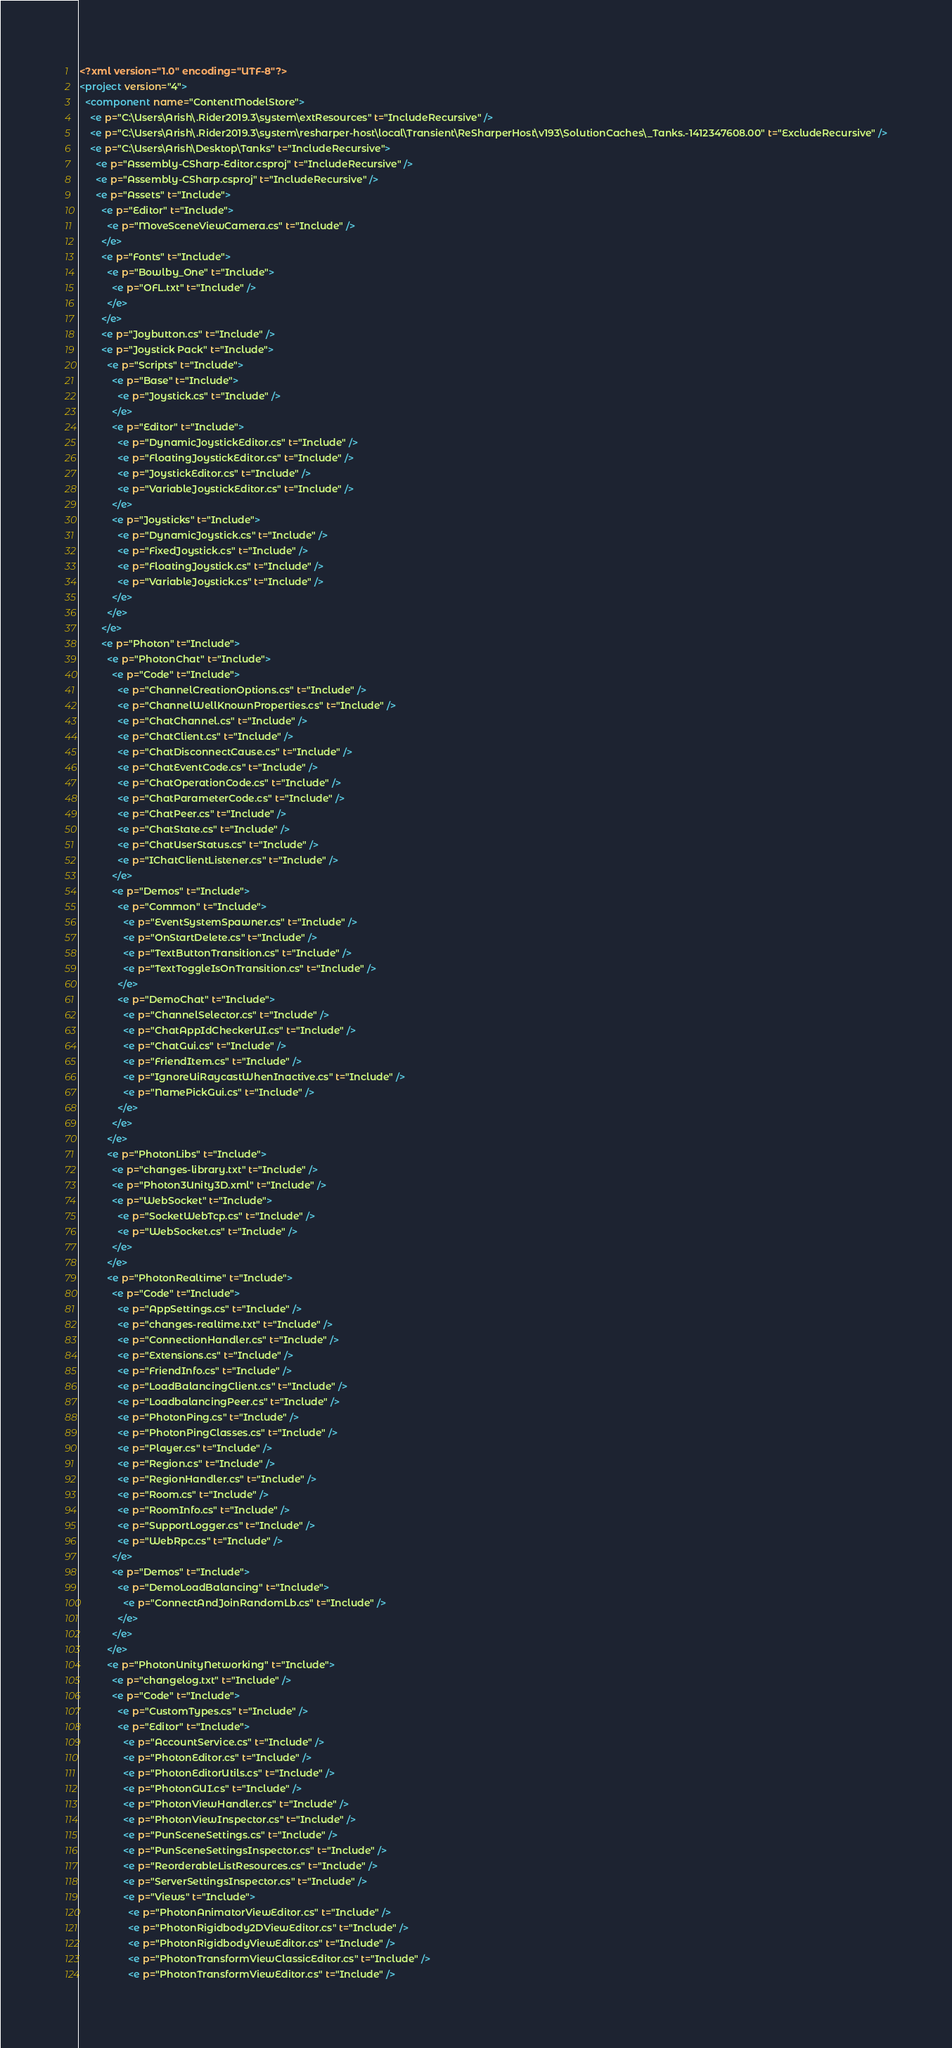Convert code to text. <code><loc_0><loc_0><loc_500><loc_500><_XML_><?xml version="1.0" encoding="UTF-8"?>
<project version="4">
  <component name="ContentModelStore">
    <e p="C:\Users\Arish\.Rider2019.3\system\extResources" t="IncludeRecursive" />
    <e p="C:\Users\Arish\.Rider2019.3\system\resharper-host\local\Transient\ReSharperHost\v193\SolutionCaches\_Tanks.-1412347608.00" t="ExcludeRecursive" />
    <e p="C:\Users\Arish\Desktop\Tanks" t="IncludeRecursive">
      <e p="Assembly-CSharp-Editor.csproj" t="IncludeRecursive" />
      <e p="Assembly-CSharp.csproj" t="IncludeRecursive" />
      <e p="Assets" t="Include">
        <e p="Editor" t="Include">
          <e p="MoveSceneViewCamera.cs" t="Include" />
        </e>
        <e p="Fonts" t="Include">
          <e p="Bowlby_One" t="Include">
            <e p="OFL.txt" t="Include" />
          </e>
        </e>
        <e p="Joybutton.cs" t="Include" />
        <e p="Joystick Pack" t="Include">
          <e p="Scripts" t="Include">
            <e p="Base" t="Include">
              <e p="Joystick.cs" t="Include" />
            </e>
            <e p="Editor" t="Include">
              <e p="DynamicJoystickEditor.cs" t="Include" />
              <e p="FloatingJoystickEditor.cs" t="Include" />
              <e p="JoystickEditor.cs" t="Include" />
              <e p="VariableJoystickEditor.cs" t="Include" />
            </e>
            <e p="Joysticks" t="Include">
              <e p="DynamicJoystick.cs" t="Include" />
              <e p="FixedJoystick.cs" t="Include" />
              <e p="FloatingJoystick.cs" t="Include" />
              <e p="VariableJoystick.cs" t="Include" />
            </e>
          </e>
        </e>
        <e p="Photon" t="Include">
          <e p="PhotonChat" t="Include">
            <e p="Code" t="Include">
              <e p="ChannelCreationOptions.cs" t="Include" />
              <e p="ChannelWellKnownProperties.cs" t="Include" />
              <e p="ChatChannel.cs" t="Include" />
              <e p="ChatClient.cs" t="Include" />
              <e p="ChatDisconnectCause.cs" t="Include" />
              <e p="ChatEventCode.cs" t="Include" />
              <e p="ChatOperationCode.cs" t="Include" />
              <e p="ChatParameterCode.cs" t="Include" />
              <e p="ChatPeer.cs" t="Include" />
              <e p="ChatState.cs" t="Include" />
              <e p="ChatUserStatus.cs" t="Include" />
              <e p="IChatClientListener.cs" t="Include" />
            </e>
            <e p="Demos" t="Include">
              <e p="Common" t="Include">
                <e p="EventSystemSpawner.cs" t="Include" />
                <e p="OnStartDelete.cs" t="Include" />
                <e p="TextButtonTransition.cs" t="Include" />
                <e p="TextToggleIsOnTransition.cs" t="Include" />
              </e>
              <e p="DemoChat" t="Include">
                <e p="ChannelSelector.cs" t="Include" />
                <e p="ChatAppIdCheckerUI.cs" t="Include" />
                <e p="ChatGui.cs" t="Include" />
                <e p="FriendItem.cs" t="Include" />
                <e p="IgnoreUiRaycastWhenInactive.cs" t="Include" />
                <e p="NamePickGui.cs" t="Include" />
              </e>
            </e>
          </e>
          <e p="PhotonLibs" t="Include">
            <e p="changes-library.txt" t="Include" />
            <e p="Photon3Unity3D.xml" t="Include" />
            <e p="WebSocket" t="Include">
              <e p="SocketWebTcp.cs" t="Include" />
              <e p="WebSocket.cs" t="Include" />
            </e>
          </e>
          <e p="PhotonRealtime" t="Include">
            <e p="Code" t="Include">
              <e p="AppSettings.cs" t="Include" />
              <e p="changes-realtime.txt" t="Include" />
              <e p="ConnectionHandler.cs" t="Include" />
              <e p="Extensions.cs" t="Include" />
              <e p="FriendInfo.cs" t="Include" />
              <e p="LoadBalancingClient.cs" t="Include" />
              <e p="LoadbalancingPeer.cs" t="Include" />
              <e p="PhotonPing.cs" t="Include" />
              <e p="PhotonPingClasses.cs" t="Include" />
              <e p="Player.cs" t="Include" />
              <e p="Region.cs" t="Include" />
              <e p="RegionHandler.cs" t="Include" />
              <e p="Room.cs" t="Include" />
              <e p="RoomInfo.cs" t="Include" />
              <e p="SupportLogger.cs" t="Include" />
              <e p="WebRpc.cs" t="Include" />
            </e>
            <e p="Demos" t="Include">
              <e p="DemoLoadBalancing" t="Include">
                <e p="ConnectAndJoinRandomLb.cs" t="Include" />
              </e>
            </e>
          </e>
          <e p="PhotonUnityNetworking" t="Include">
            <e p="changelog.txt" t="Include" />
            <e p="Code" t="Include">
              <e p="CustomTypes.cs" t="Include" />
              <e p="Editor" t="Include">
                <e p="AccountService.cs" t="Include" />
                <e p="PhotonEditor.cs" t="Include" />
                <e p="PhotonEditorUtils.cs" t="Include" />
                <e p="PhotonGUI.cs" t="Include" />
                <e p="PhotonViewHandler.cs" t="Include" />
                <e p="PhotonViewInspector.cs" t="Include" />
                <e p="PunSceneSettings.cs" t="Include" />
                <e p="PunSceneSettingsInspector.cs" t="Include" />
                <e p="ReorderableListResources.cs" t="Include" />
                <e p="ServerSettingsInspector.cs" t="Include" />
                <e p="Views" t="Include">
                  <e p="PhotonAnimatorViewEditor.cs" t="Include" />
                  <e p="PhotonRigidbody2DViewEditor.cs" t="Include" />
                  <e p="PhotonRigidbodyViewEditor.cs" t="Include" />
                  <e p="PhotonTransformViewClassicEditor.cs" t="Include" />
                  <e p="PhotonTransformViewEditor.cs" t="Include" /></code> 